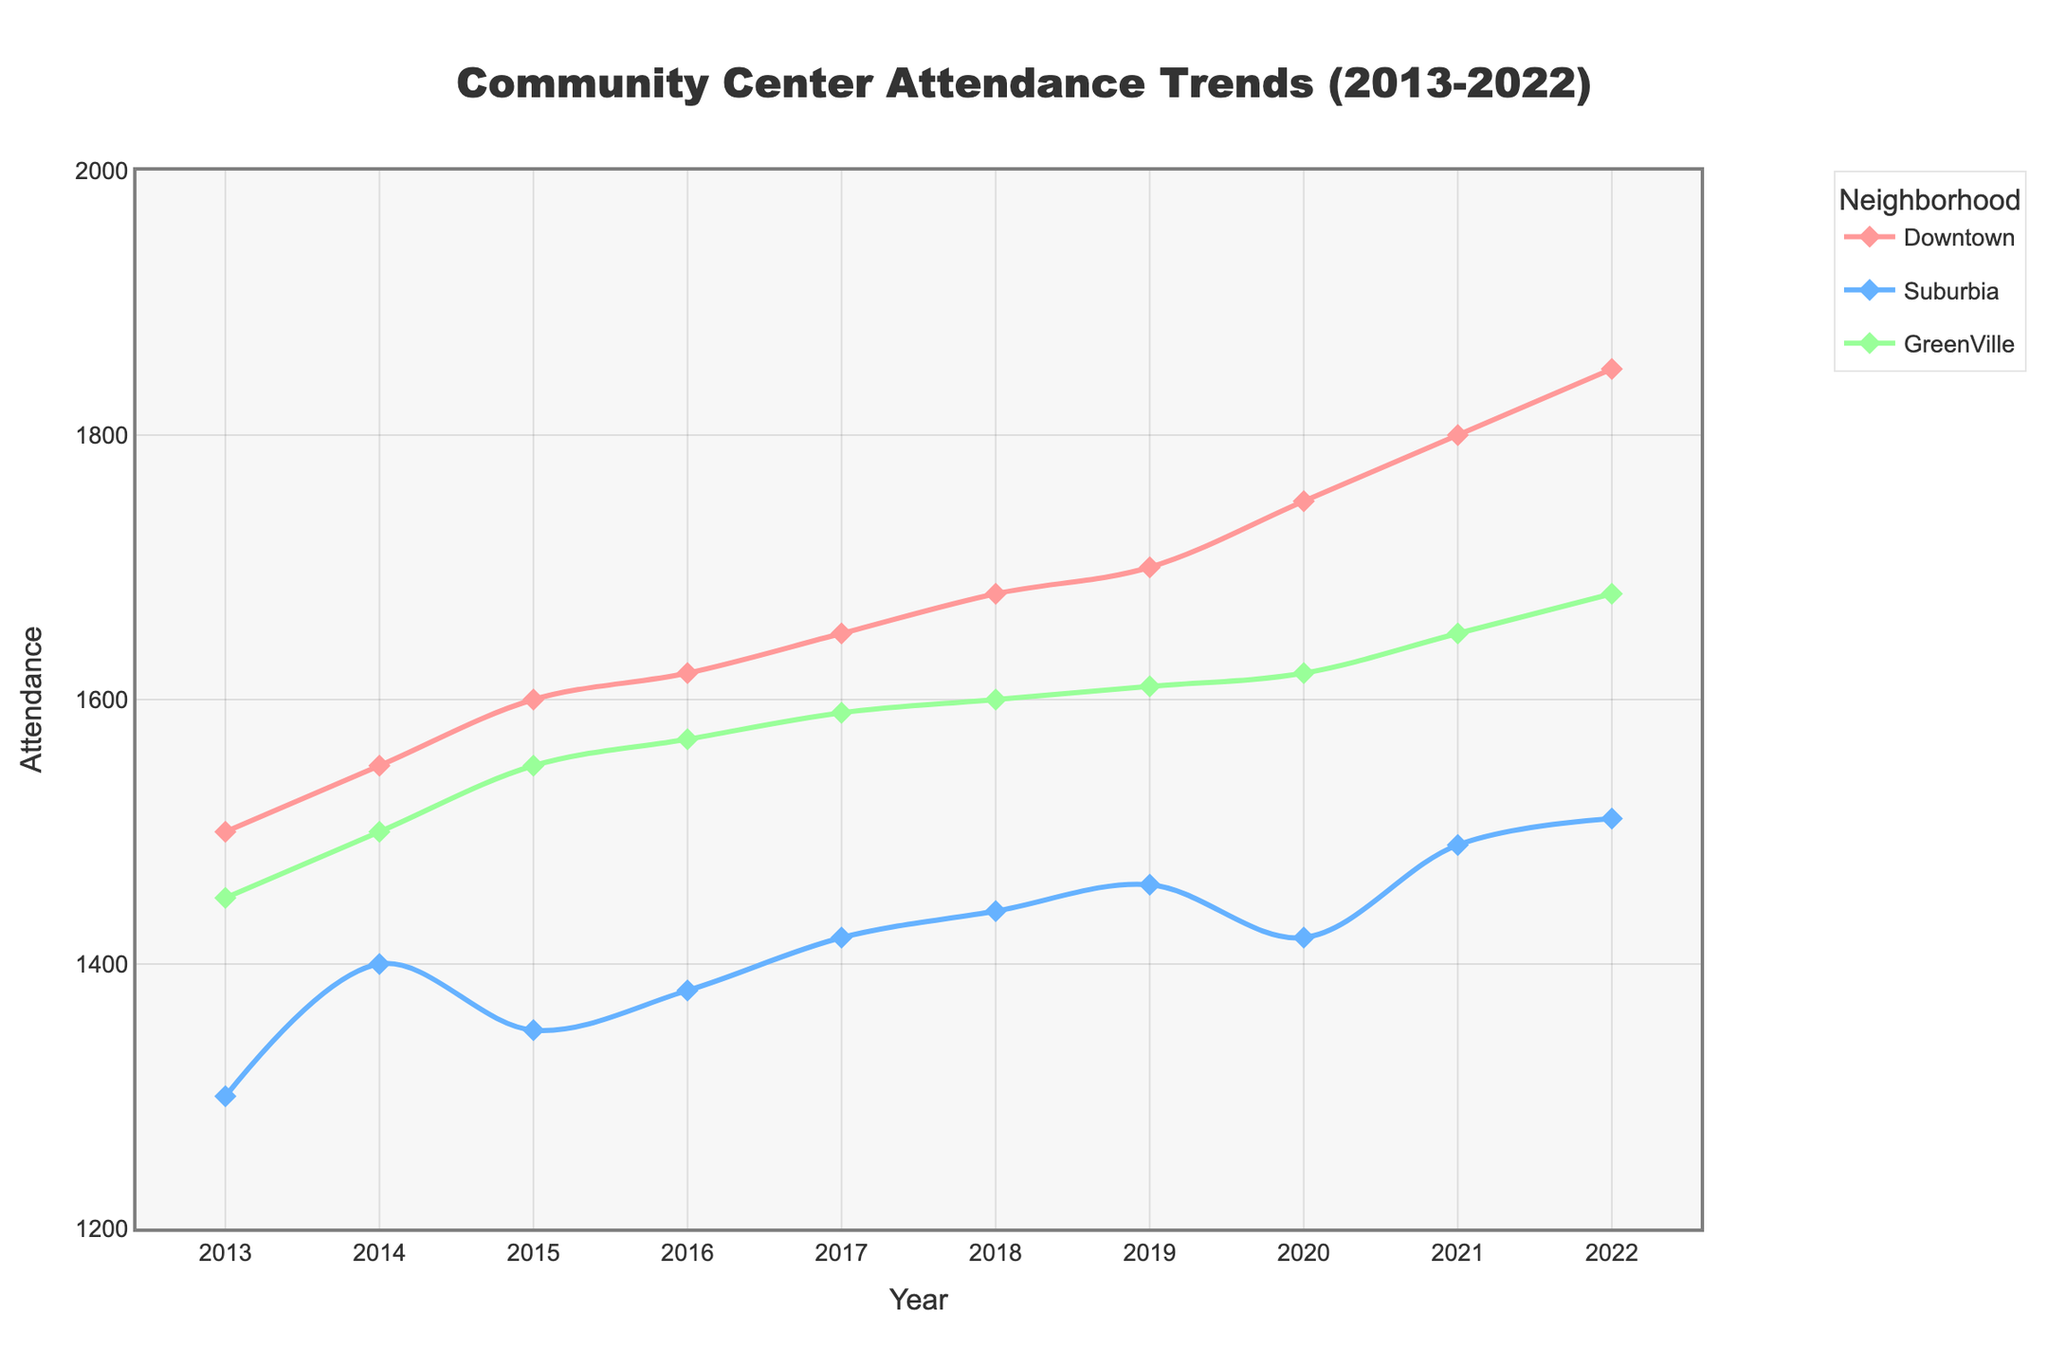What is the title of the plot? The title is located at the top center of the plot and reads 'Community Center Attendance Trends (2013-2022)'.
Answer: Community Center Attendance Trends (2013-2022) Which neighborhood has the highest attendance in 2022? To find the highest attendance in 2022, look at the y-axis values for different neighborhoods at the 2022 marker on the x-axis. Downtown reaches 1850, which is the highest.
Answer: Downtown How did the attendance in Suburbia change from 2013 to 2022? Observe the y-axis values for Suburbia at 2013 and 2022. In 2013, it was 1300, and in 2022, it was 1510. Subtracting 1300 from 1510 gives an increase of 210.
Answer: Increased by 210 What is the overall trend in attendance for GreenVille over the past decade? View the y-axis values for GreenVille from 2013 to 2022. Attendance shows a general upward trend, starting at 1450 in 2013 and rising to 1680 in 2022.
Answer: Upward trend Compare the attendance trends in Downtown and Suburbia between 2015 and 2017, which neighborhood saw a larger increase? For Downtown, attendance grows from 1600 in 2015 to 1650 in 2017, an increase of 50. For Suburbia, it goes from 1350 in 2015 to 1420 in 2017, an increase of 70. Suburbia saw a larger increase.
Answer: Suburbia What year did GreenVille's attendance surpass 1600? Review the plot for GreenVille and find the first year where the y-axis value exceeds 1600. This occurs in 2018.
Answer: 2018 What is the average attendance for Downtown from 2013 to 2022? Sum the attendance figures for Downtown from 2013 to 2022 and then divide by the total number of years (10). The sum is (1500 + 1550 + 1600 + 1620 + 1650 + 1680 + 1700 + 1750 + 1800 + 1850) = 16650. The average is 16650/10 = 1665.
Answer: 1665 Which year saw the largest single-year increase in attendance for Downtown? Calculate the yearly differences. The largest difference occurs between 2019 (1700) and 2020 (1750), with an increase of 50.
Answer: 2020 What was the attendance for all neighborhoods combined in 2020? Sum the attendance values for Downtown, Suburbia, and GreenVille in 2020. That is 1750 (Downtown) + 1420 (Suburbia) + 1620 (GreenVille) = 4790.
Answer: 4790 Did any neighborhood experience a year-to-year decrease in attendance? Compare the y-axis values for each neighborhood year by year. Suburbia experiences a decrease from 1460 in 2019 to 1420 in 2020.
Answer: Yes, Suburbia 